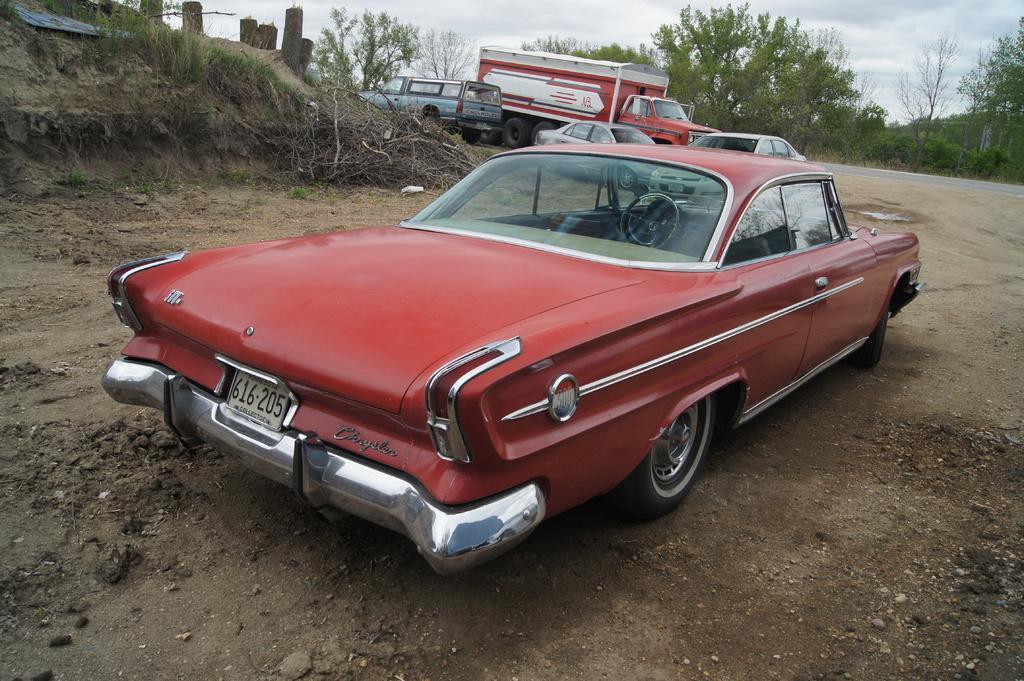In one or two sentences, can you explain what this image depicts? In the foreground of this image, there is a red color car on the ground. In the background, there are few vehicles, trees and few pillars on the left. On the top, there is the cloud. 